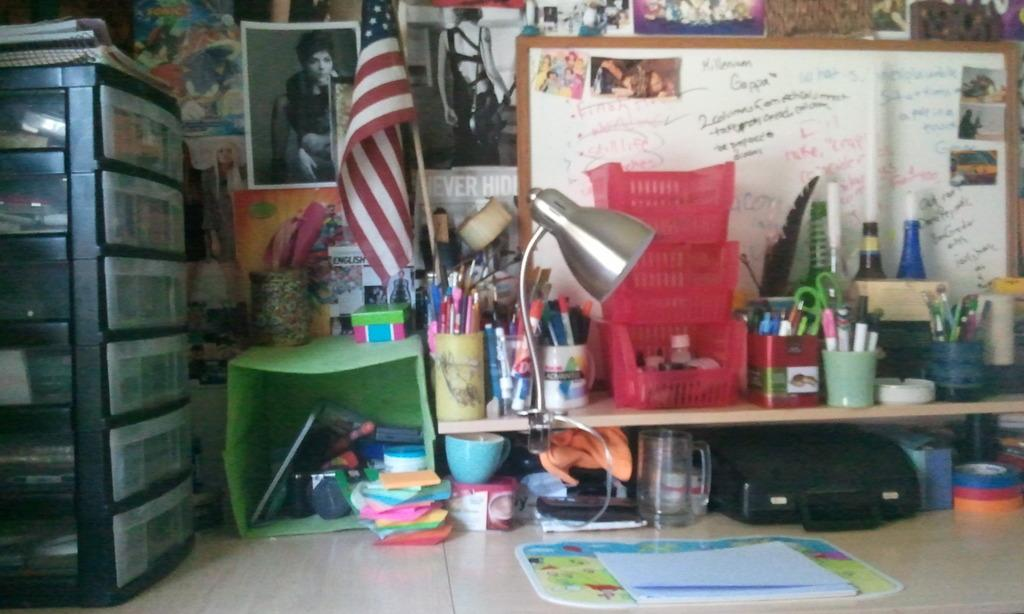<image>
Render a clear and concise summary of the photo. On the wall behind the desk there is a picture that says "Never Hide." 